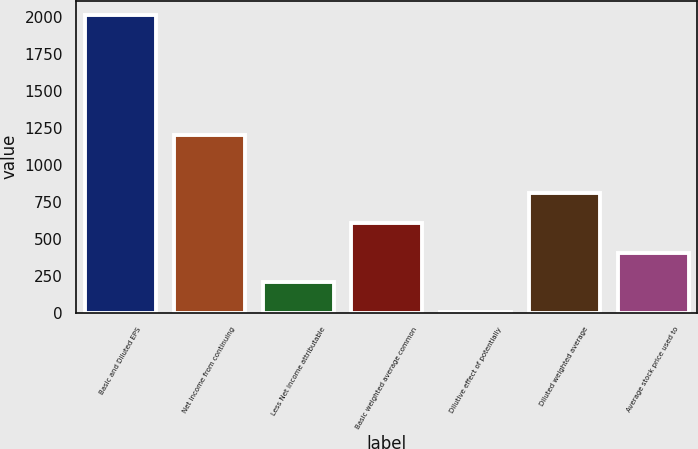Convert chart. <chart><loc_0><loc_0><loc_500><loc_500><bar_chart><fcel>Basic and Diluted EPS<fcel>Net income from continuing<fcel>Less Net income attributable<fcel>Basic weighted average common<fcel>Dilutive effect of potentially<fcel>Diluted weighted average<fcel>Average stock price used to<nl><fcel>2012<fcel>1204<fcel>208.4<fcel>609.2<fcel>8<fcel>809.6<fcel>408.8<nl></chart> 